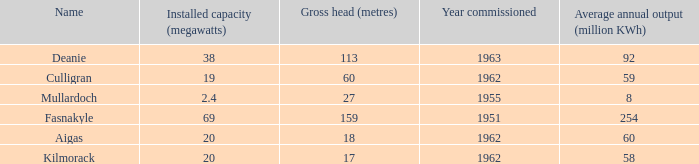What is the Year commissioned of the power station with a Gross head of 60 metres and Average annual output of less than 59 million KWh? None. 